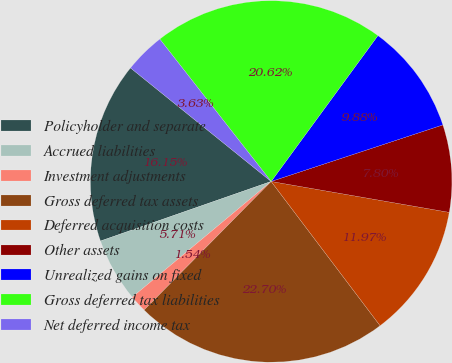Convert chart to OTSL. <chart><loc_0><loc_0><loc_500><loc_500><pie_chart><fcel>Policyholder and separate<fcel>Accrued liabilities<fcel>Investment adjustments<fcel>Gross deferred tax assets<fcel>Deferred acquisition costs<fcel>Other assets<fcel>Unrealized gains on fixed<fcel>Gross deferred tax liabilities<fcel>Net deferred income tax<nl><fcel>16.15%<fcel>5.71%<fcel>1.54%<fcel>22.7%<fcel>11.97%<fcel>7.8%<fcel>9.88%<fcel>20.62%<fcel>3.63%<nl></chart> 